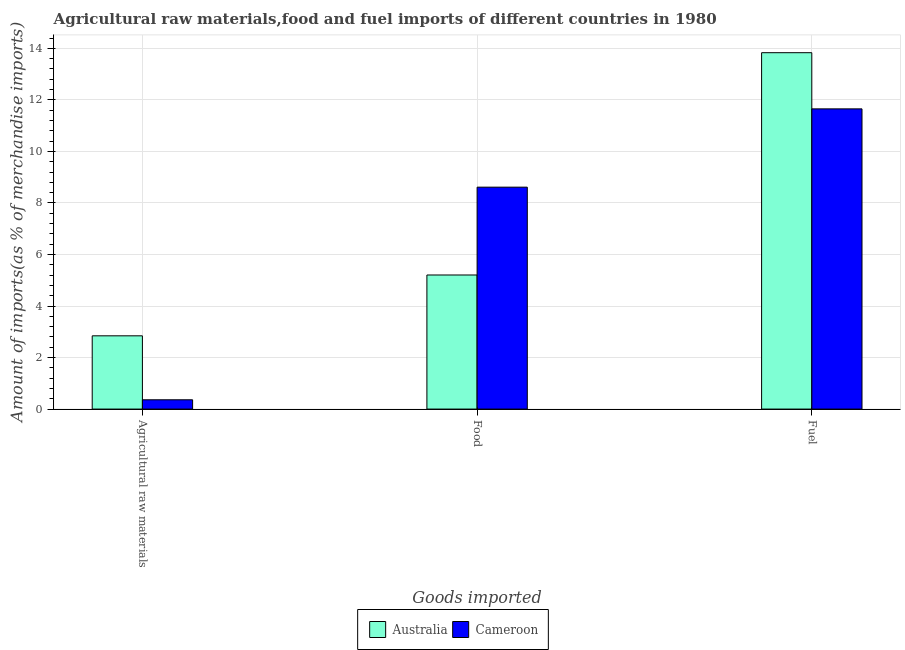Are the number of bars per tick equal to the number of legend labels?
Your answer should be compact. Yes. Are the number of bars on each tick of the X-axis equal?
Keep it short and to the point. Yes. How many bars are there on the 3rd tick from the left?
Your answer should be very brief. 2. How many bars are there on the 3rd tick from the right?
Give a very brief answer. 2. What is the label of the 1st group of bars from the left?
Keep it short and to the point. Agricultural raw materials. What is the percentage of raw materials imports in Cameroon?
Provide a succinct answer. 0.36. Across all countries, what is the maximum percentage of food imports?
Your answer should be compact. 8.61. Across all countries, what is the minimum percentage of food imports?
Your answer should be very brief. 5.2. In which country was the percentage of food imports maximum?
Give a very brief answer. Cameroon. In which country was the percentage of food imports minimum?
Provide a succinct answer. Australia. What is the total percentage of food imports in the graph?
Offer a terse response. 13.82. What is the difference between the percentage of food imports in Cameroon and that in Australia?
Your response must be concise. 3.41. What is the difference between the percentage of food imports in Cameroon and the percentage of raw materials imports in Australia?
Your answer should be very brief. 5.77. What is the average percentage of fuel imports per country?
Make the answer very short. 12.74. What is the difference between the percentage of food imports and percentage of raw materials imports in Cameroon?
Offer a very short reply. 8.25. In how many countries, is the percentage of raw materials imports greater than 10.4 %?
Keep it short and to the point. 0. What is the ratio of the percentage of raw materials imports in Cameroon to that in Australia?
Keep it short and to the point. 0.13. What is the difference between the highest and the second highest percentage of raw materials imports?
Give a very brief answer. 2.48. What is the difference between the highest and the lowest percentage of raw materials imports?
Provide a succinct answer. 2.48. What does the 2nd bar from the left in Agricultural raw materials represents?
Your answer should be compact. Cameroon. How many bars are there?
Your answer should be compact. 6. Are all the bars in the graph horizontal?
Your response must be concise. No. What is the difference between two consecutive major ticks on the Y-axis?
Provide a short and direct response. 2. Does the graph contain grids?
Provide a short and direct response. Yes. Where does the legend appear in the graph?
Keep it short and to the point. Bottom center. What is the title of the graph?
Keep it short and to the point. Agricultural raw materials,food and fuel imports of different countries in 1980. Does "Norway" appear as one of the legend labels in the graph?
Keep it short and to the point. No. What is the label or title of the X-axis?
Ensure brevity in your answer.  Goods imported. What is the label or title of the Y-axis?
Your response must be concise. Amount of imports(as % of merchandise imports). What is the Amount of imports(as % of merchandise imports) of Australia in Agricultural raw materials?
Your answer should be very brief. 2.84. What is the Amount of imports(as % of merchandise imports) of Cameroon in Agricultural raw materials?
Keep it short and to the point. 0.36. What is the Amount of imports(as % of merchandise imports) in Australia in Food?
Keep it short and to the point. 5.2. What is the Amount of imports(as % of merchandise imports) of Cameroon in Food?
Offer a very short reply. 8.61. What is the Amount of imports(as % of merchandise imports) in Australia in Fuel?
Your response must be concise. 13.83. What is the Amount of imports(as % of merchandise imports) of Cameroon in Fuel?
Provide a short and direct response. 11.65. Across all Goods imported, what is the maximum Amount of imports(as % of merchandise imports) in Australia?
Keep it short and to the point. 13.83. Across all Goods imported, what is the maximum Amount of imports(as % of merchandise imports) of Cameroon?
Your answer should be compact. 11.65. Across all Goods imported, what is the minimum Amount of imports(as % of merchandise imports) of Australia?
Offer a very short reply. 2.84. Across all Goods imported, what is the minimum Amount of imports(as % of merchandise imports) in Cameroon?
Ensure brevity in your answer.  0.36. What is the total Amount of imports(as % of merchandise imports) in Australia in the graph?
Your answer should be compact. 21.88. What is the total Amount of imports(as % of merchandise imports) in Cameroon in the graph?
Your answer should be very brief. 20.63. What is the difference between the Amount of imports(as % of merchandise imports) of Australia in Agricultural raw materials and that in Food?
Offer a terse response. -2.36. What is the difference between the Amount of imports(as % of merchandise imports) in Cameroon in Agricultural raw materials and that in Food?
Keep it short and to the point. -8.25. What is the difference between the Amount of imports(as % of merchandise imports) in Australia in Agricultural raw materials and that in Fuel?
Make the answer very short. -10.99. What is the difference between the Amount of imports(as % of merchandise imports) of Cameroon in Agricultural raw materials and that in Fuel?
Keep it short and to the point. -11.29. What is the difference between the Amount of imports(as % of merchandise imports) of Australia in Food and that in Fuel?
Give a very brief answer. -8.63. What is the difference between the Amount of imports(as % of merchandise imports) in Cameroon in Food and that in Fuel?
Make the answer very short. -3.04. What is the difference between the Amount of imports(as % of merchandise imports) in Australia in Agricultural raw materials and the Amount of imports(as % of merchandise imports) in Cameroon in Food?
Your answer should be very brief. -5.77. What is the difference between the Amount of imports(as % of merchandise imports) in Australia in Agricultural raw materials and the Amount of imports(as % of merchandise imports) in Cameroon in Fuel?
Keep it short and to the point. -8.81. What is the difference between the Amount of imports(as % of merchandise imports) of Australia in Food and the Amount of imports(as % of merchandise imports) of Cameroon in Fuel?
Provide a short and direct response. -6.45. What is the average Amount of imports(as % of merchandise imports) of Australia per Goods imported?
Your answer should be very brief. 7.29. What is the average Amount of imports(as % of merchandise imports) in Cameroon per Goods imported?
Offer a very short reply. 6.88. What is the difference between the Amount of imports(as % of merchandise imports) in Australia and Amount of imports(as % of merchandise imports) in Cameroon in Agricultural raw materials?
Keep it short and to the point. 2.48. What is the difference between the Amount of imports(as % of merchandise imports) of Australia and Amount of imports(as % of merchandise imports) of Cameroon in Food?
Provide a succinct answer. -3.41. What is the difference between the Amount of imports(as % of merchandise imports) of Australia and Amount of imports(as % of merchandise imports) of Cameroon in Fuel?
Your answer should be compact. 2.18. What is the ratio of the Amount of imports(as % of merchandise imports) in Australia in Agricultural raw materials to that in Food?
Offer a very short reply. 0.55. What is the ratio of the Amount of imports(as % of merchandise imports) in Cameroon in Agricultural raw materials to that in Food?
Offer a very short reply. 0.04. What is the ratio of the Amount of imports(as % of merchandise imports) of Australia in Agricultural raw materials to that in Fuel?
Keep it short and to the point. 0.21. What is the ratio of the Amount of imports(as % of merchandise imports) in Cameroon in Agricultural raw materials to that in Fuel?
Your answer should be compact. 0.03. What is the ratio of the Amount of imports(as % of merchandise imports) in Australia in Food to that in Fuel?
Offer a terse response. 0.38. What is the ratio of the Amount of imports(as % of merchandise imports) of Cameroon in Food to that in Fuel?
Offer a very short reply. 0.74. What is the difference between the highest and the second highest Amount of imports(as % of merchandise imports) of Australia?
Your response must be concise. 8.63. What is the difference between the highest and the second highest Amount of imports(as % of merchandise imports) of Cameroon?
Your response must be concise. 3.04. What is the difference between the highest and the lowest Amount of imports(as % of merchandise imports) in Australia?
Ensure brevity in your answer.  10.99. What is the difference between the highest and the lowest Amount of imports(as % of merchandise imports) of Cameroon?
Keep it short and to the point. 11.29. 